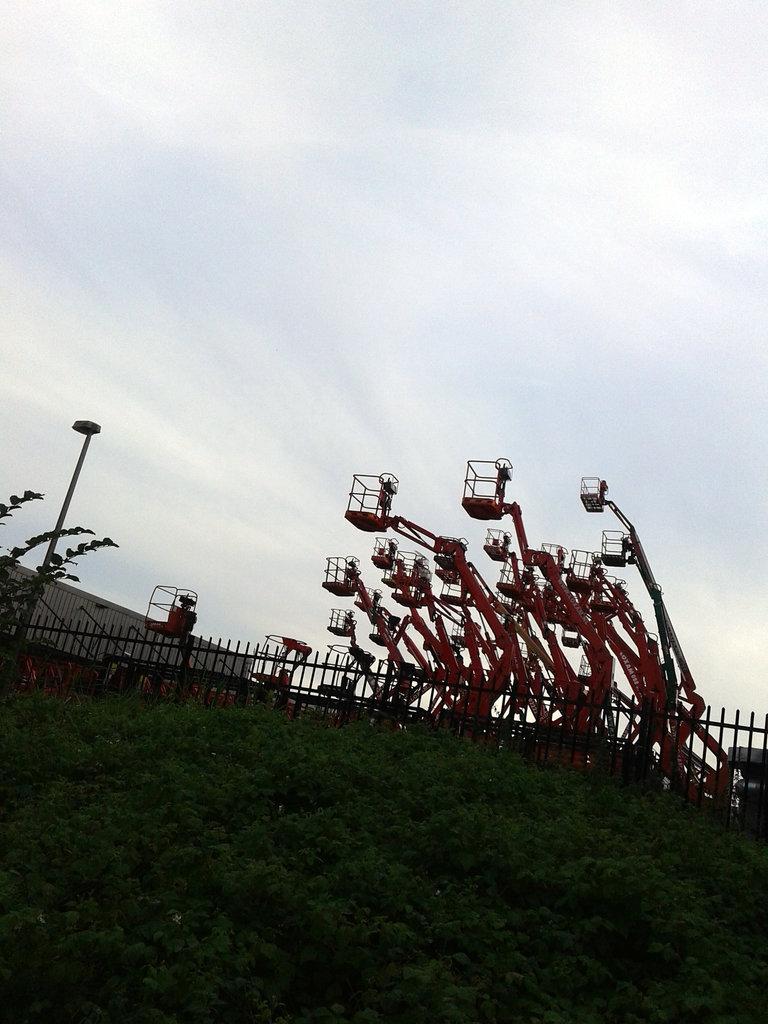Could you give a brief overview of what you see in this image? In this image we can see some plants, there is fencing and in the background of the image there are some street light fitting vehicles and top of the image there is clear sky. 